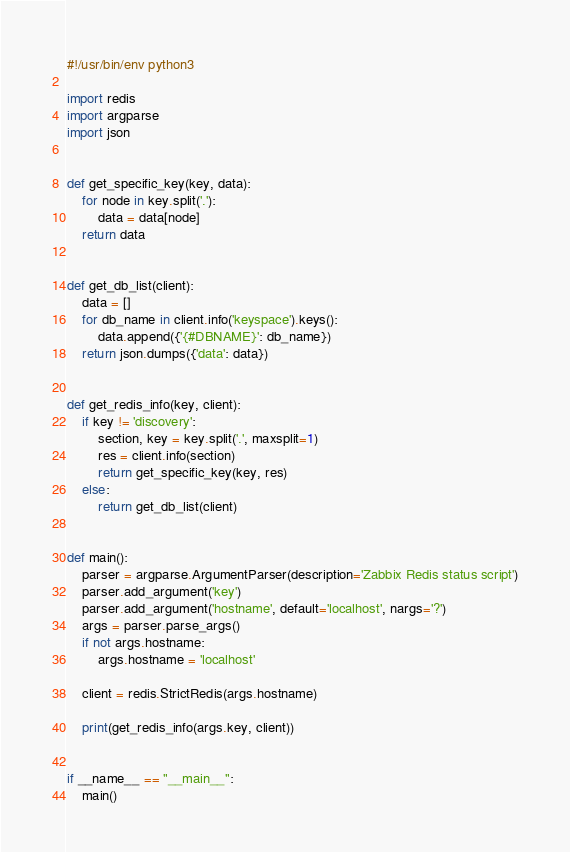<code> <loc_0><loc_0><loc_500><loc_500><_Python_>#!/usr/bin/env python3

import redis
import argparse
import json


def get_specific_key(key, data):
    for node in key.split('.'):
        data = data[node]
    return data


def get_db_list(client):
    data = []
    for db_name in client.info('keyspace').keys():
        data.append({'{#DBNAME}': db_name})
    return json.dumps({'data': data})


def get_redis_info(key, client):
    if key != 'discovery':
        section, key = key.split('.', maxsplit=1)
        res = client.info(section)
        return get_specific_key(key, res)
    else:
        return get_db_list(client)


def main():
    parser = argparse.ArgumentParser(description='Zabbix Redis status script')
    parser.add_argument('key')
    parser.add_argument('hostname', default='localhost', nargs='?')
    args = parser.parse_args()
    if not args.hostname:
        args.hostname = 'localhost'

    client = redis.StrictRedis(args.hostname)

    print(get_redis_info(args.key, client))


if __name__ == "__main__":
    main()
</code> 